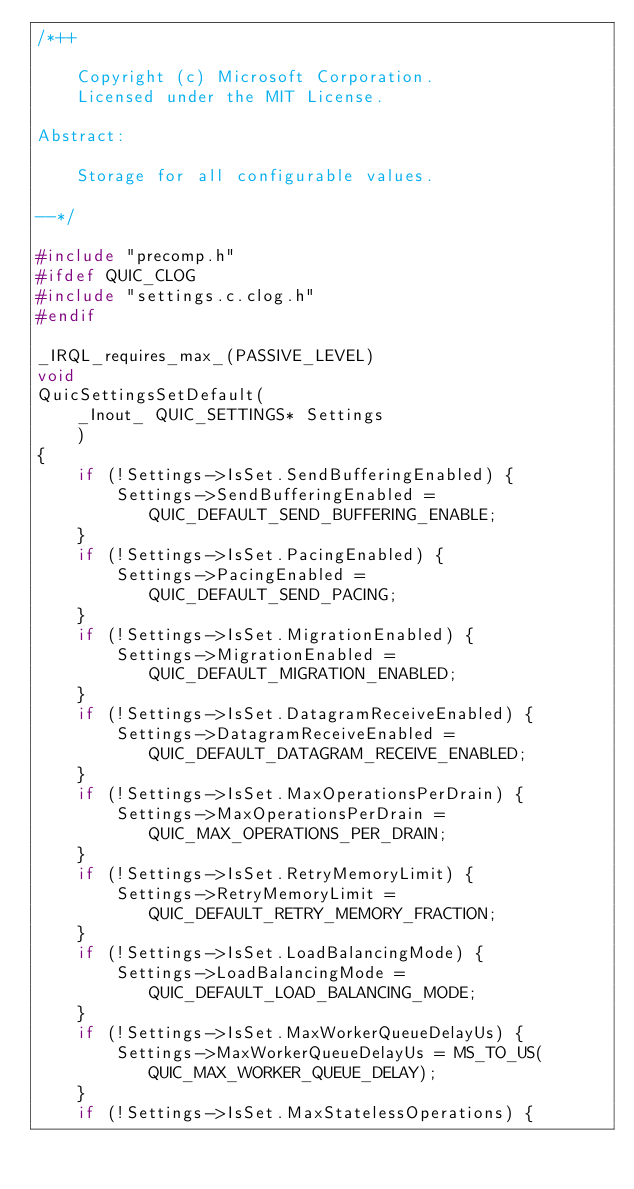<code> <loc_0><loc_0><loc_500><loc_500><_C_>/*++

    Copyright (c) Microsoft Corporation.
    Licensed under the MIT License.

Abstract:

    Storage for all configurable values.

--*/

#include "precomp.h"
#ifdef QUIC_CLOG
#include "settings.c.clog.h"
#endif

_IRQL_requires_max_(PASSIVE_LEVEL)
void
QuicSettingsSetDefault(
    _Inout_ QUIC_SETTINGS* Settings
    )
{
    if (!Settings->IsSet.SendBufferingEnabled) {
        Settings->SendBufferingEnabled = QUIC_DEFAULT_SEND_BUFFERING_ENABLE;
    }
    if (!Settings->IsSet.PacingEnabled) {
        Settings->PacingEnabled = QUIC_DEFAULT_SEND_PACING;
    }
    if (!Settings->IsSet.MigrationEnabled) {
        Settings->MigrationEnabled = QUIC_DEFAULT_MIGRATION_ENABLED;
    }
    if (!Settings->IsSet.DatagramReceiveEnabled) {
        Settings->DatagramReceiveEnabled = QUIC_DEFAULT_DATAGRAM_RECEIVE_ENABLED;
    }
    if (!Settings->IsSet.MaxOperationsPerDrain) {
        Settings->MaxOperationsPerDrain = QUIC_MAX_OPERATIONS_PER_DRAIN;
    }
    if (!Settings->IsSet.RetryMemoryLimit) {
        Settings->RetryMemoryLimit = QUIC_DEFAULT_RETRY_MEMORY_FRACTION;
    }
    if (!Settings->IsSet.LoadBalancingMode) {
        Settings->LoadBalancingMode = QUIC_DEFAULT_LOAD_BALANCING_MODE;
    }
    if (!Settings->IsSet.MaxWorkerQueueDelayUs) {
        Settings->MaxWorkerQueueDelayUs = MS_TO_US(QUIC_MAX_WORKER_QUEUE_DELAY);
    }
    if (!Settings->IsSet.MaxStatelessOperations) {</code> 